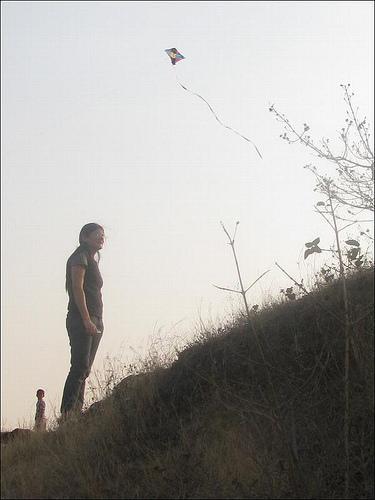Is this a sport?
Be succinct. No. Is this a recent picture?
Short answer required. Yes. Where is the woman looking?
Answer briefly. To right. Are there green leaves on the trees?
Answer briefly. No. Is the ground wet?
Short answer required. No. What is the woman doing?
Answer briefly. Watching. Is it summer?
Give a very brief answer. Yes. Are there horses shown?
Concise answer only. No. Are they jumping off of a building?
Give a very brief answer. No. Is there a hill in this picture?
Keep it brief. Yes. What season is the  picture taken?
Answer briefly. Fall. What are the purple things?
Answer briefly. Kite. Is the woman skiing?
Write a very short answer. No. Does this person appear to be squinting in the sunlight?
Keep it brief. No. Where is the person looking?
Write a very short answer. Right. Is it cold?
Concise answer only. No. Is this woman a model?
Write a very short answer. No. Is the person male or female?
Quick response, please. Female. Is this person doing an activity?
Short answer required. No. Is it cold in this picture?
Short answer required. No. Is she posing for the picture?
Keep it brief. No. What kind of park is the kid in?
Concise answer only. Empty. What is covering the ground?
Quick response, please. Grass. How many people are watching?
Short answer required. 1. Does this grass need to be watered?
Short answer required. No. What is the man doing?
Answer briefly. Standing. Formal or casual?
Quick response, please. Casual. What is this person doing?
Be succinct. Standing. What activity did she participate in?
Answer briefly. Kite flying. What gender is the child?
Short answer required. Female. What color is the woman's hair?
Give a very brief answer. Brown. Is the girl watching the kite?
Answer briefly. No. Is this a recent photo?
Give a very brief answer. Yes. 